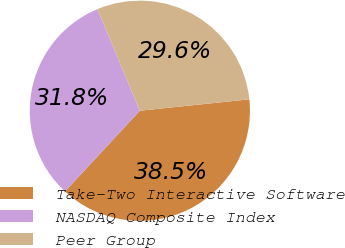Convert chart to OTSL. <chart><loc_0><loc_0><loc_500><loc_500><pie_chart><fcel>Take-Two Interactive Software<fcel>NASDAQ Composite Index<fcel>Peer Group<nl><fcel>38.55%<fcel>31.81%<fcel>29.64%<nl></chart> 